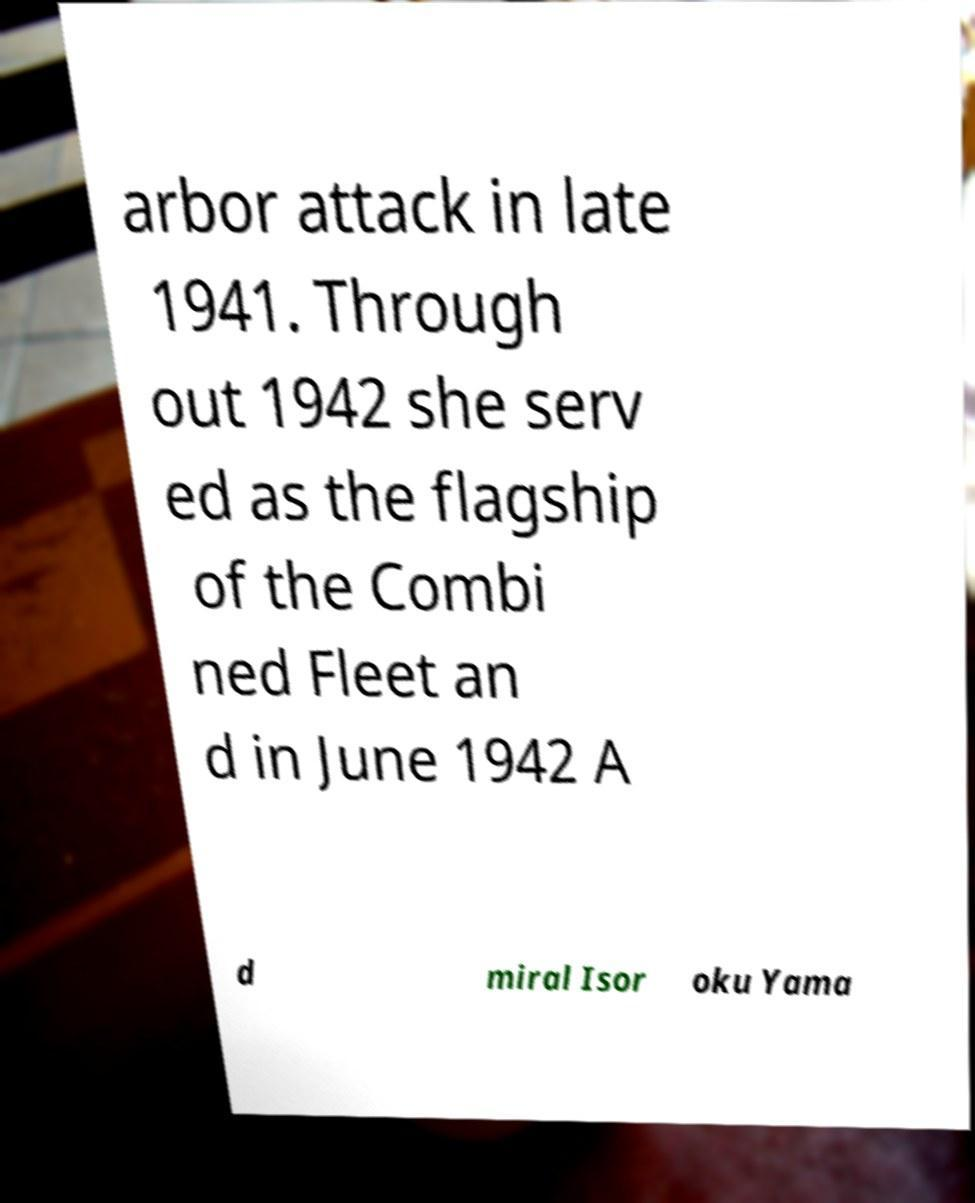There's text embedded in this image that I need extracted. Can you transcribe it verbatim? arbor attack in late 1941. Through out 1942 she serv ed as the flagship of the Combi ned Fleet an d in June 1942 A d miral Isor oku Yama 